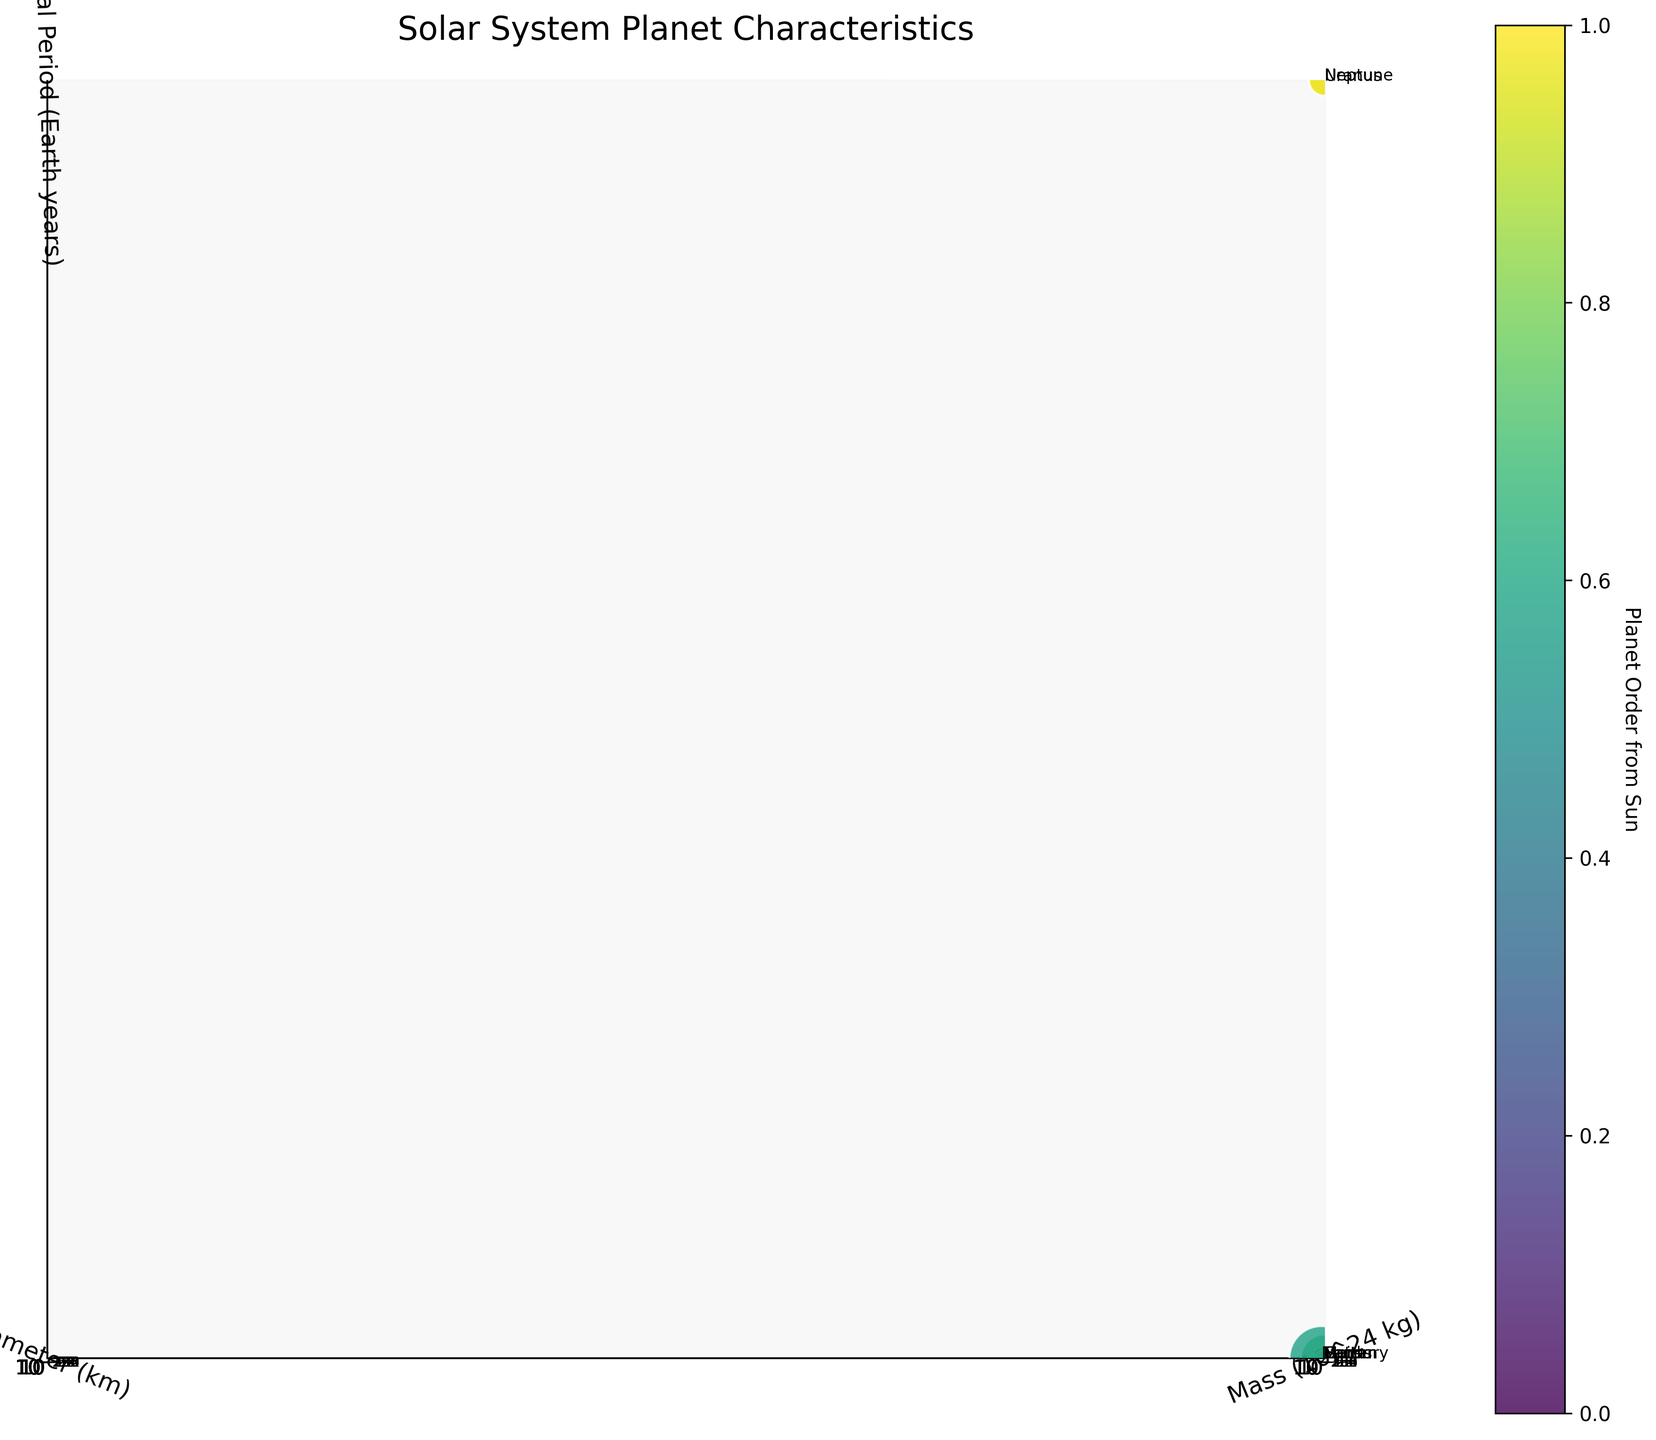How many planets are represented in the figure? Count the number of data points or labels provided for each planet in the scatter plot. With 8 planets in the solar system shown, each data point represents a planet.
Answer: 8 Which planet has the largest diameter? Look at the scatter plot along the y-axis, which represents the diameter. The planet with the highest position on the y-axis is Jupiter.
Answer: Jupiter Which planet has the shortest orbital period? Examine the z-axis, which signifies the orbital period. The planet at the lowest point on the z-axis has the shortest orbital period, which is Mercury.
Answer: Mercury What is the relationship between mass and diameter among the planets? Assess the scatter plot's spread along the x-axis (mass) and y-axis (diameter). Generally, planets with higher mass tend to also have larger diameters, indicating a positive correlation.
Answer: Positive correlation Which planet is labeled as having both high mass and a long orbital period? Look for the data point positioned towards the higher ends of both the x-axis (mass) and z-axis (orbital period). Jupiter, being the most massive planet, has a significant orbital period as well.
Answer: Jupiter Which two planets have similar orbital periods but different diameters? Compare the planets' positions along the z-axis (orbital period) and then check their corresponding y-axis (diameter) values. Earth and Mars have similar orbital periods but different diameters.
Answer: Earth and Mars How does the diameter of Neptune compare to that of Uranus? Locate Neptune and Uranus on the scatter plot, observing their positions along the y-axis (diameter). Neptune has a smaller diameter than Uranus.
Answer: Uranus has a larger diameter than Neptune Which planet has the smallest mass, and how is it represented in the plot? Identify the smallest data point size, as sizes are normalized to represent masses. Mercury is the planet with the smallest mass, represented by the smallest point.
Answer: Mercury If you have to highlight one contrast, which planet shows the greatest difference in mass compared to others? Compare the sizes of the data points, observing which one stands out the most in size. Jupiter has the greatest mass difference compared to the other planets, as indicated by its substantially larger data point.
Answer: Jupiter 